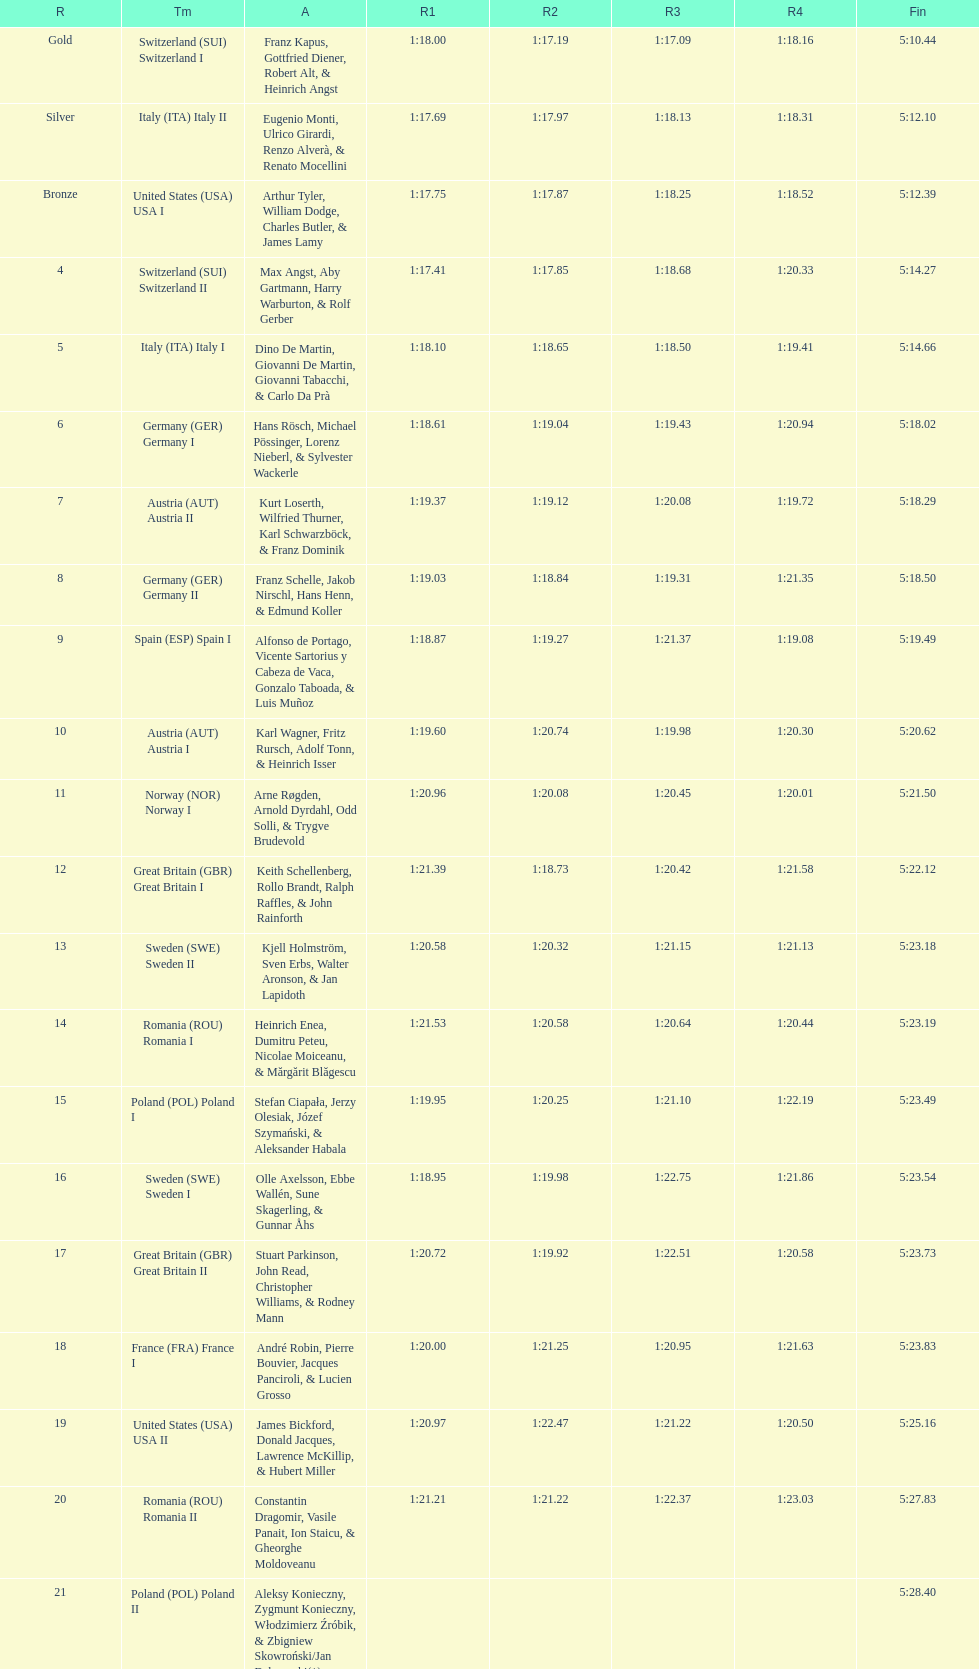Which team scored the highest number of runs? Switzerland. 